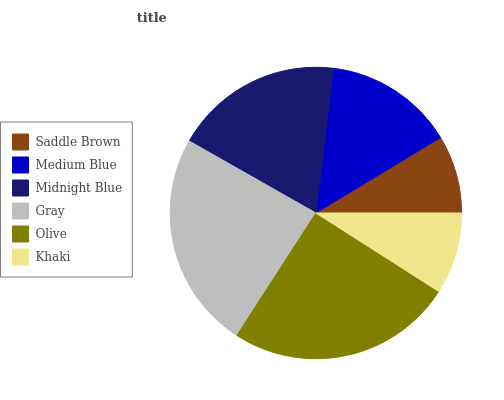Is Saddle Brown the minimum?
Answer yes or no. Yes. Is Olive the maximum?
Answer yes or no. Yes. Is Medium Blue the minimum?
Answer yes or no. No. Is Medium Blue the maximum?
Answer yes or no. No. Is Medium Blue greater than Saddle Brown?
Answer yes or no. Yes. Is Saddle Brown less than Medium Blue?
Answer yes or no. Yes. Is Saddle Brown greater than Medium Blue?
Answer yes or no. No. Is Medium Blue less than Saddle Brown?
Answer yes or no. No. Is Midnight Blue the high median?
Answer yes or no. Yes. Is Medium Blue the low median?
Answer yes or no. Yes. Is Saddle Brown the high median?
Answer yes or no. No. Is Midnight Blue the low median?
Answer yes or no. No. 